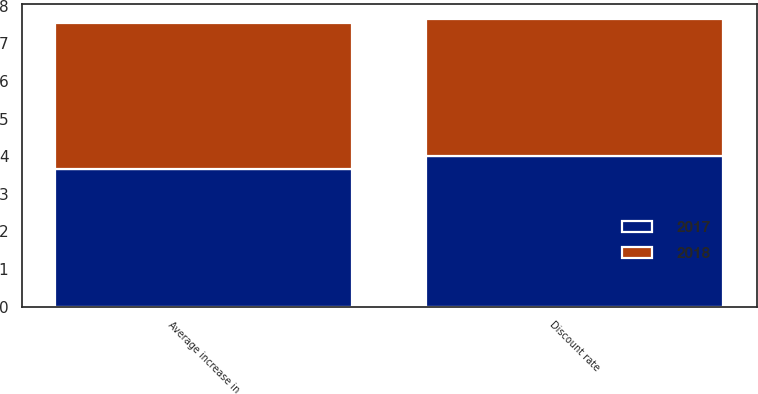<chart> <loc_0><loc_0><loc_500><loc_500><stacked_bar_chart><ecel><fcel>Discount rate<fcel>Average increase in<nl><fcel>2017<fcel>4.01<fcel>3.65<nl><fcel>2018<fcel>3.64<fcel>3.89<nl></chart> 